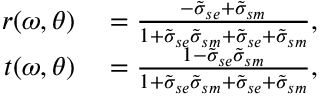Convert formula to latex. <formula><loc_0><loc_0><loc_500><loc_500>\begin{array} { r l } { r ( \omega , \theta ) } & = \frac { - \tilde { \sigma } _ { s e } + \tilde { \sigma } _ { s m } } { 1 + \tilde { \sigma } _ { s e } \tilde { \sigma } _ { s m } + \tilde { \sigma } _ { s e } + \tilde { \sigma } _ { s m } } , } \\ { t ( \omega , \theta ) } & = \frac { 1 - \tilde { \sigma } _ { s e } \tilde { \sigma } _ { s m } } { 1 + \tilde { \sigma } _ { s e } \tilde { \sigma } _ { s m } + \tilde { \sigma } _ { s e } + \tilde { \sigma } _ { s m } } , } \end{array}</formula> 